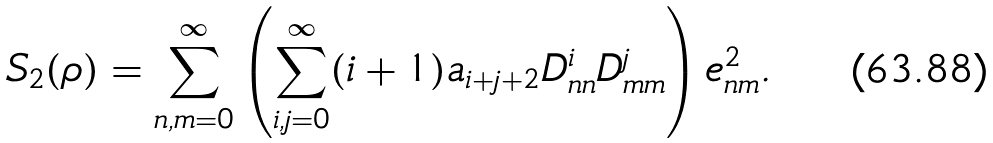Convert formula to latex. <formula><loc_0><loc_0><loc_500><loc_500>S _ { 2 } ( \rho ) = \sum _ { n , m = 0 } ^ { \infty } \left ( \sum _ { i , j = 0 } ^ { \infty } ( i + 1 ) a _ { i + j + 2 } D ^ { i } _ { n n } D ^ { j } _ { m m } \right ) e ^ { 2 } _ { n m } .</formula> 